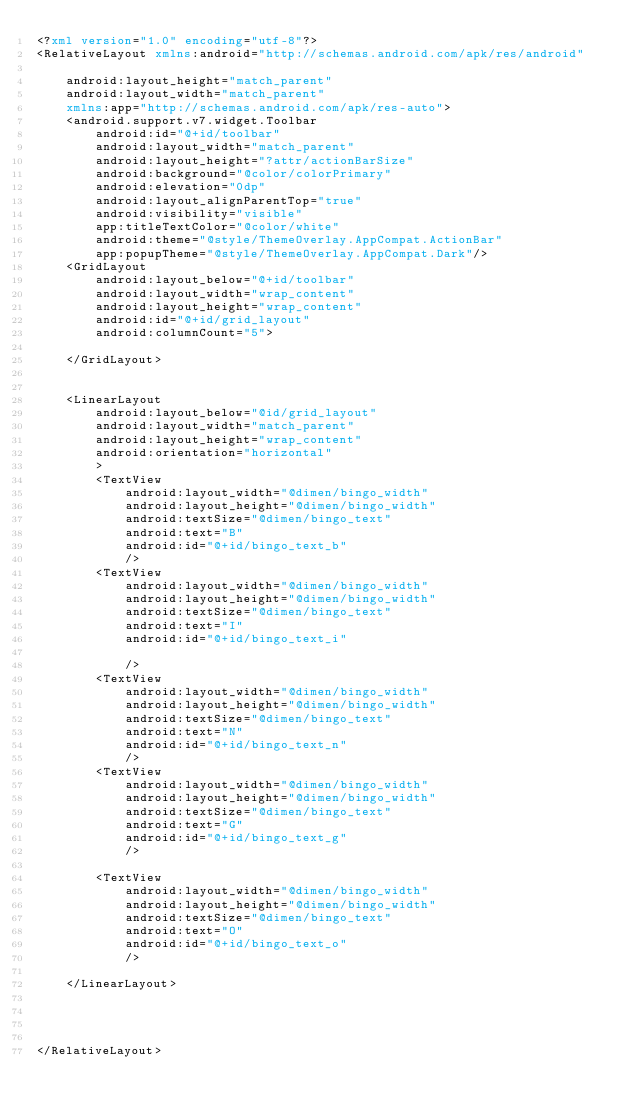Convert code to text. <code><loc_0><loc_0><loc_500><loc_500><_XML_><?xml version="1.0" encoding="utf-8"?>
<RelativeLayout xmlns:android="http://schemas.android.com/apk/res/android"

    android:layout_height="match_parent"
    android:layout_width="match_parent"
    xmlns:app="http://schemas.android.com/apk/res-auto">
    <android.support.v7.widget.Toolbar
        android:id="@+id/toolbar"
        android:layout_width="match_parent"
        android:layout_height="?attr/actionBarSize"
        android:background="@color/colorPrimary"
        android:elevation="0dp"
        android:layout_alignParentTop="true"
        android:visibility="visible"
        app:titleTextColor="@color/white"
        android:theme="@style/ThemeOverlay.AppCompat.ActionBar"
        app:popupTheme="@style/ThemeOverlay.AppCompat.Dark"/>
    <GridLayout
        android:layout_below="@+id/toolbar"
        android:layout_width="wrap_content"
        android:layout_height="wrap_content"
        android:id="@+id/grid_layout"
        android:columnCount="5">

    </GridLayout>


    <LinearLayout
        android:layout_below="@id/grid_layout"
        android:layout_width="match_parent"
        android:layout_height="wrap_content"
        android:orientation="horizontal"
        >
        <TextView
            android:layout_width="@dimen/bingo_width"
            android:layout_height="@dimen/bingo_width"
            android:textSize="@dimen/bingo_text"
            android:text="B"
            android:id="@+id/bingo_text_b"
            />
        <TextView
            android:layout_width="@dimen/bingo_width"
            android:layout_height="@dimen/bingo_width"
            android:textSize="@dimen/bingo_text"
            android:text="I"
            android:id="@+id/bingo_text_i"

            />
        <TextView
            android:layout_width="@dimen/bingo_width"
            android:layout_height="@dimen/bingo_width"
            android:textSize="@dimen/bingo_text"
            android:text="N"
            android:id="@+id/bingo_text_n"
            />
        <TextView
            android:layout_width="@dimen/bingo_width"
            android:layout_height="@dimen/bingo_width"
            android:textSize="@dimen/bingo_text"
            android:text="G"
            android:id="@+id/bingo_text_g"
            />

        <TextView
            android:layout_width="@dimen/bingo_width"
            android:layout_height="@dimen/bingo_width"
            android:textSize="@dimen/bingo_text"
            android:text="O"
            android:id="@+id/bingo_text_o"
            />

    </LinearLayout>




</RelativeLayout>

</code> 